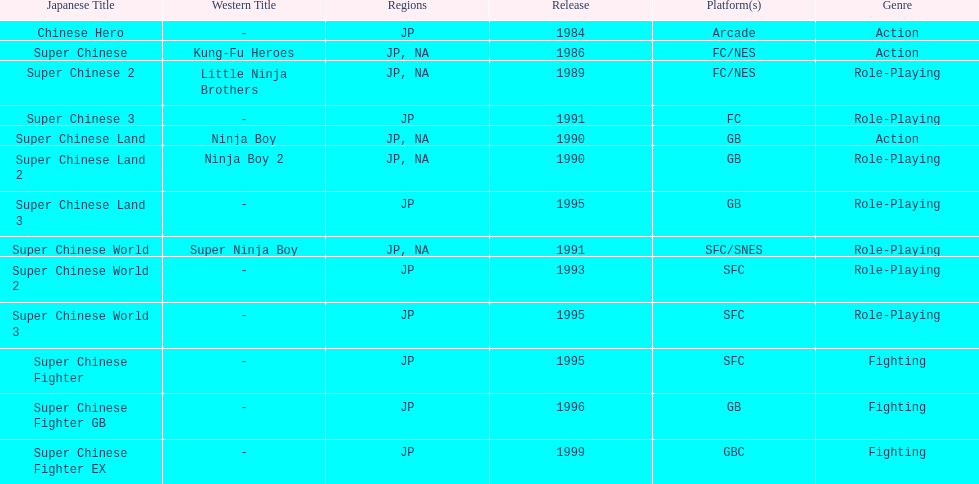What are the total of super chinese games released? 13. 